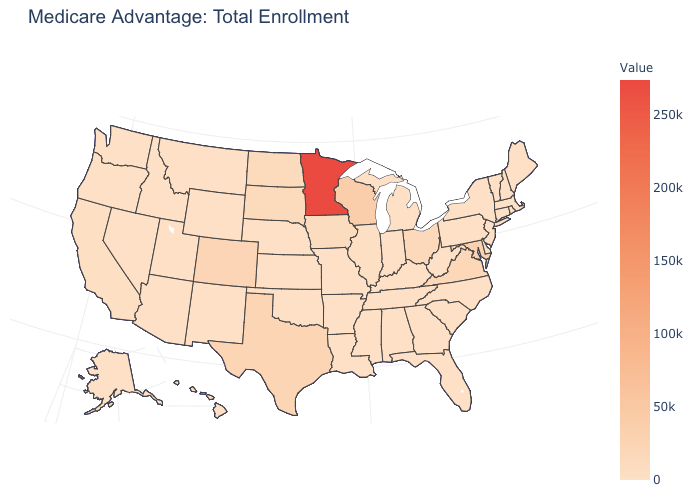Among the states that border Vermont , which have the lowest value?
Be succinct. Massachusetts, New Hampshire. Does the map have missing data?
Answer briefly. No. Does Ohio have the highest value in the MidWest?
Answer briefly. No. Does the map have missing data?
Be succinct. No. Which states have the highest value in the USA?
Write a very short answer. Minnesota. 